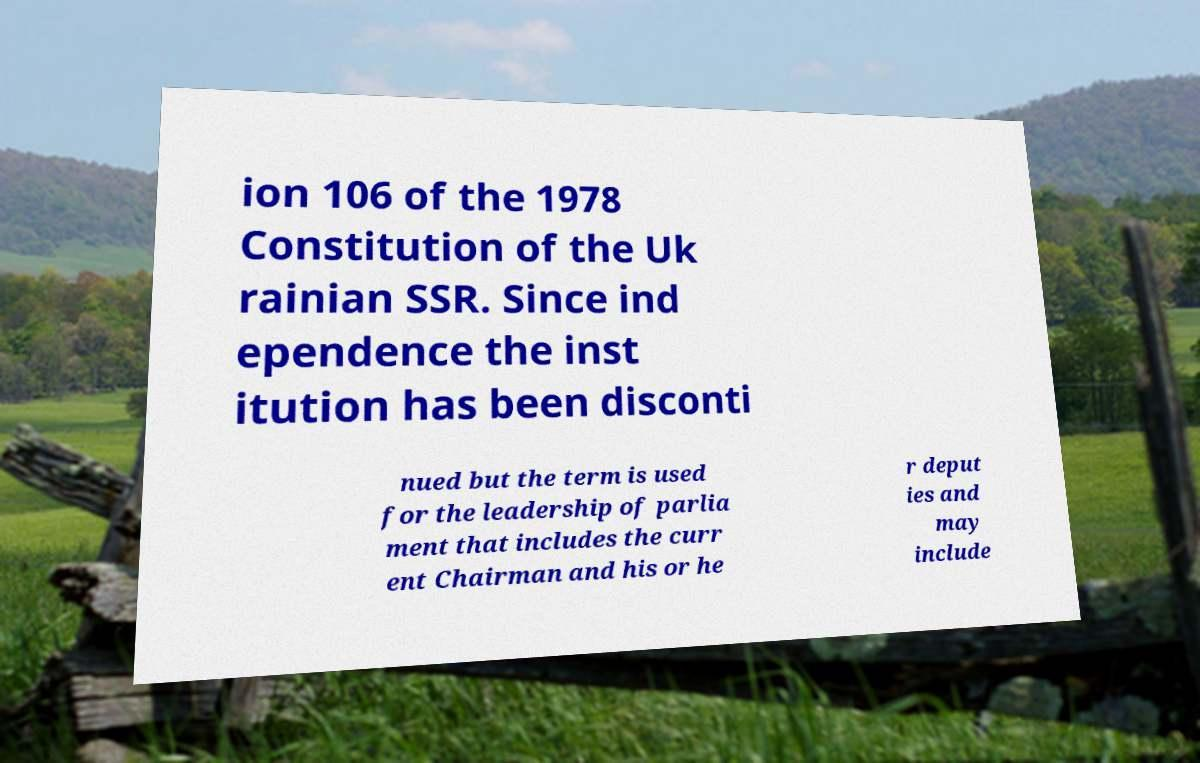Could you extract and type out the text from this image? ion 106 of the 1978 Constitution of the Uk rainian SSR. Since ind ependence the inst itution has been disconti nued but the term is used for the leadership of parlia ment that includes the curr ent Chairman and his or he r deput ies and may include 